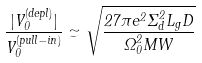Convert formula to latex. <formula><loc_0><loc_0><loc_500><loc_500>\frac { | V _ { 0 } ^ { ( d e p l ) } | } { V _ { 0 } ^ { ( p u l l - i n ) } } \simeq \sqrt { \frac { 2 7 \pi e ^ { 2 } \Sigma _ { d } ^ { 2 } L _ { g } D } { \Omega _ { 0 } ^ { 2 } M W } }</formula> 